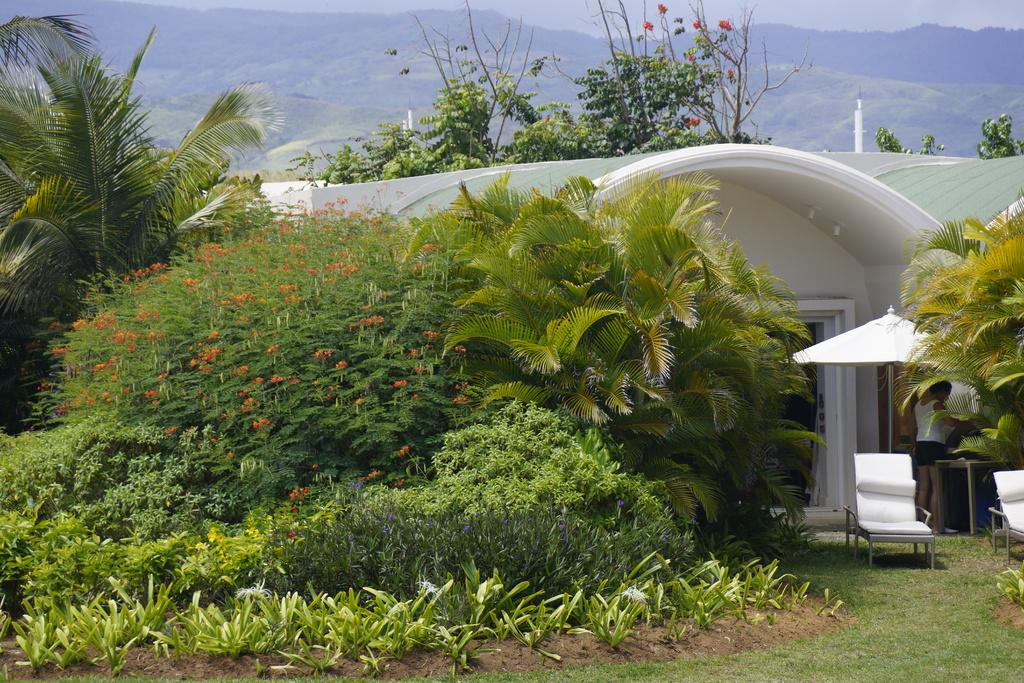What type of vegetation is present on the ground in the front of the image? There is grass on the ground in the front of the image. What can be seen in the center of the image? There are plants in the center of the image. What is visible in the background of the image? There are trees, a house, and mountains in the background of the image. Where is the hose located in the image? There is no hose present in the image. What type of twig is being used by the trees in the background? There is no specific twig mentioned or visible in the image; the trees are simply part of the background. 